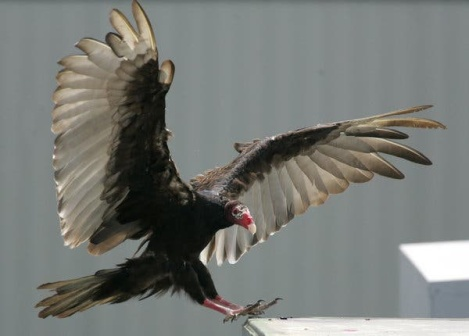What events might have led to this vulture being here? It's likely that the vulture was riding thermals, those warm updrafts that help it soar with minimal effort. Sensing something of interest below, perhaps the glint off the roof or a soft sound carried on the wind, it decided to descend for a closer look. This area might be part of its regular patrol grounds, where it searches for food or simply rests. The proximity to human construction hints at adaptation to new environments, indicating an interaction between wildlife and human expansion. 